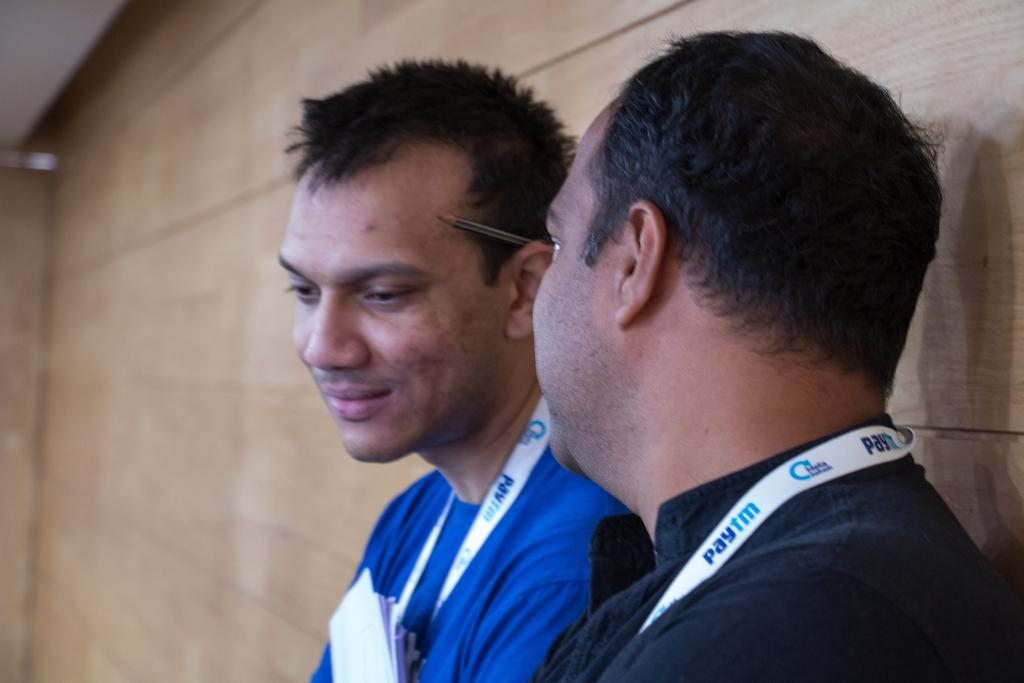<image>
Render a clear and concise summary of the photo. Man talking to another man both wearing a necklace that says paytm. 